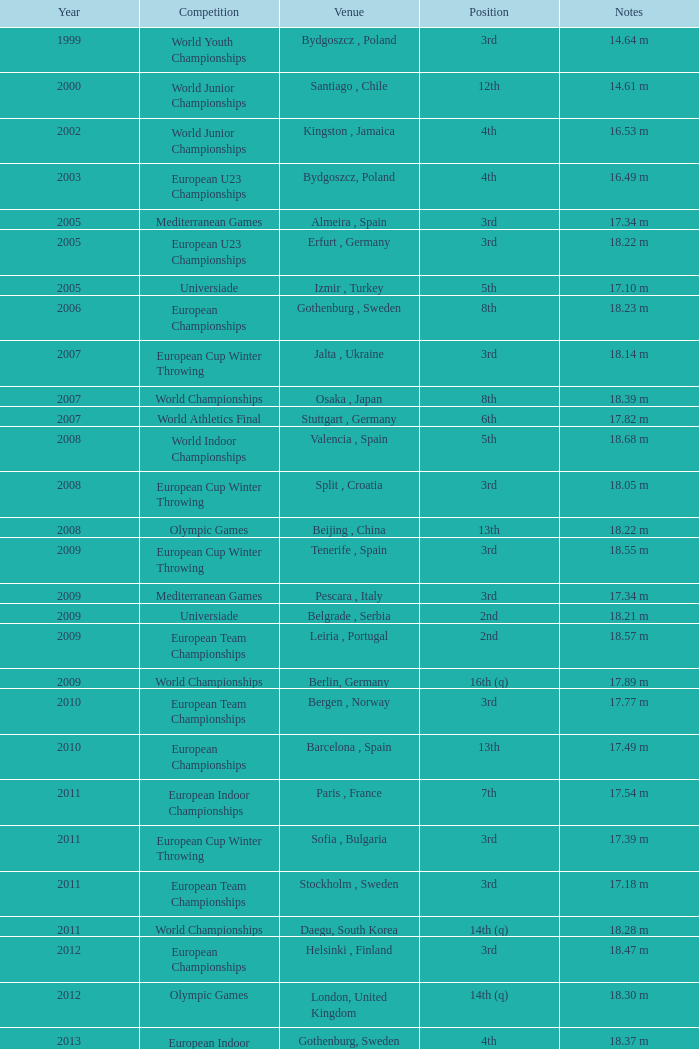Where were the Mediterranean games after 2005? Pescara , Italy. 